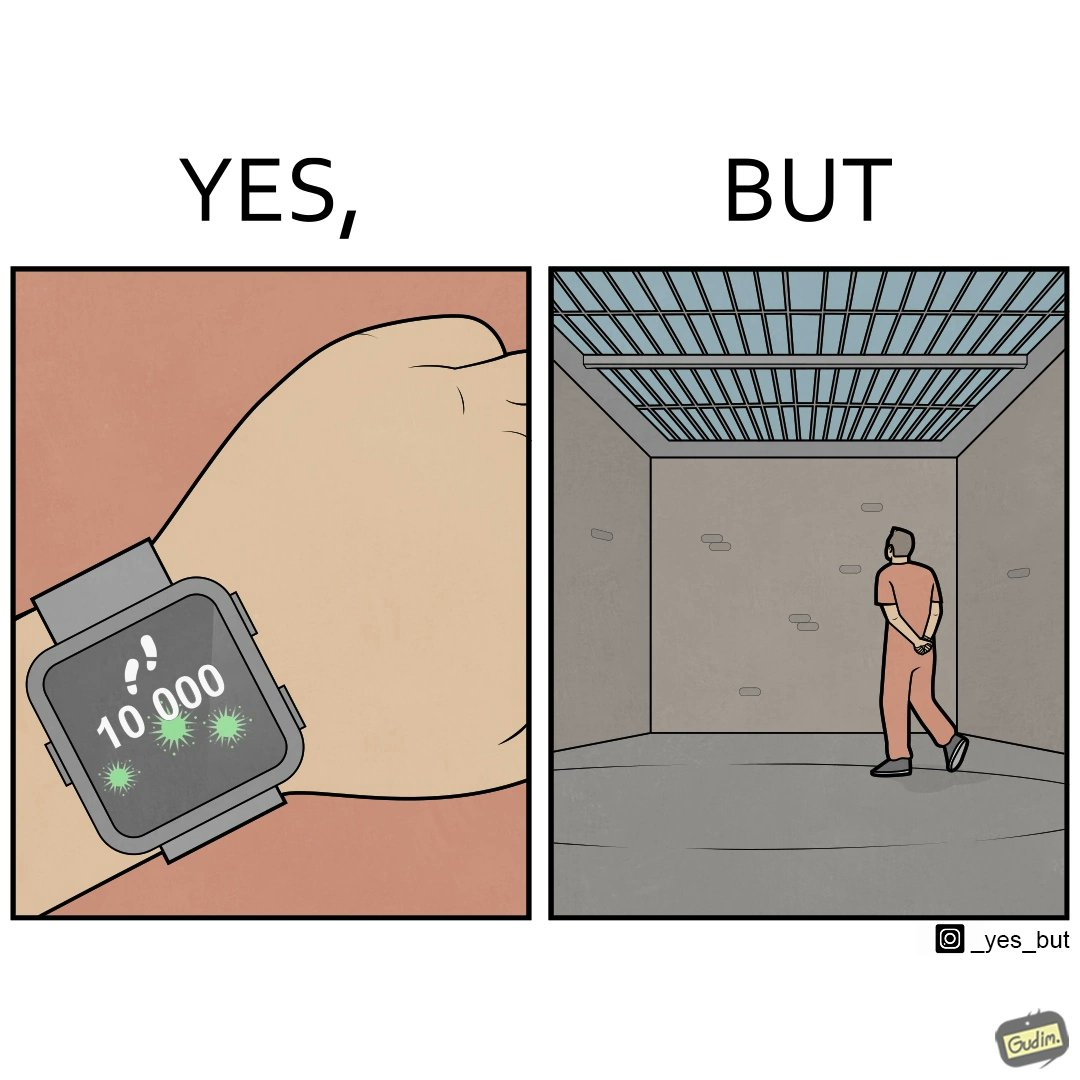Does this image contain satire or humor? Yes, this image is satirical. 